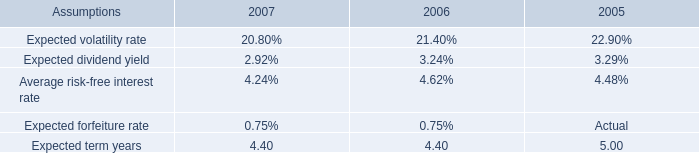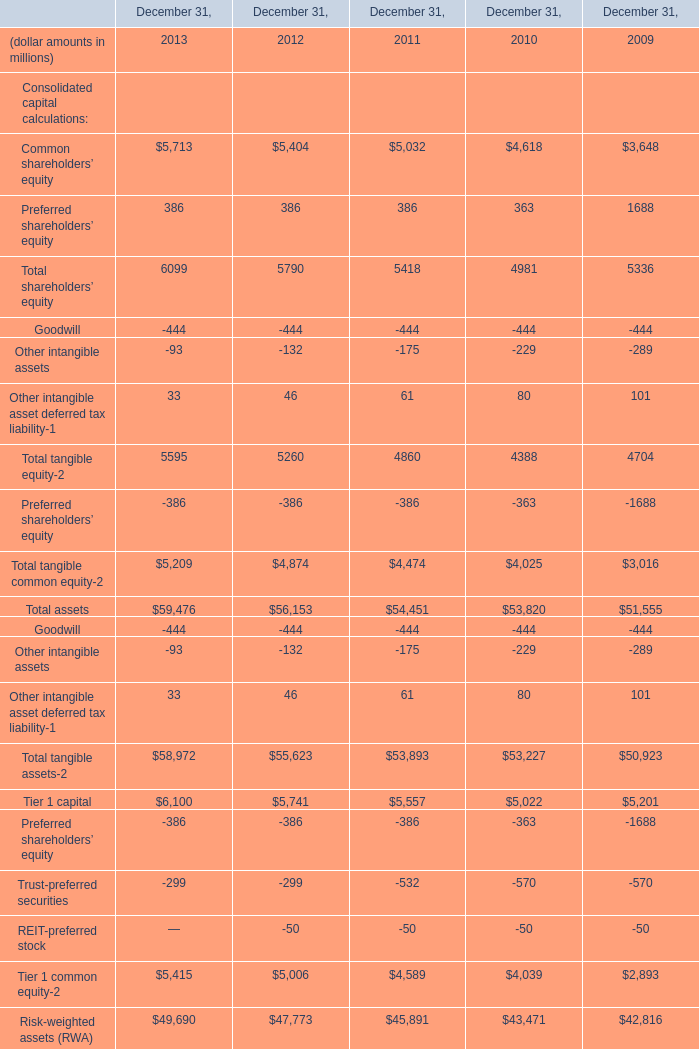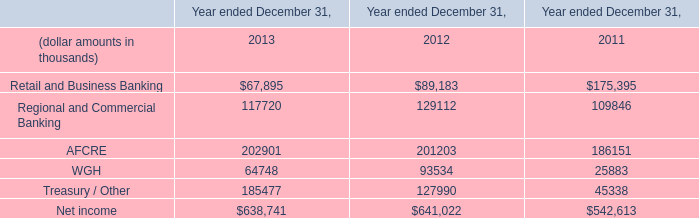What do all tangible common equity sum up, excluding those negative ones in 2012 ? (in million) 
Computations: (5260 - 386)
Answer: 4874.0. 